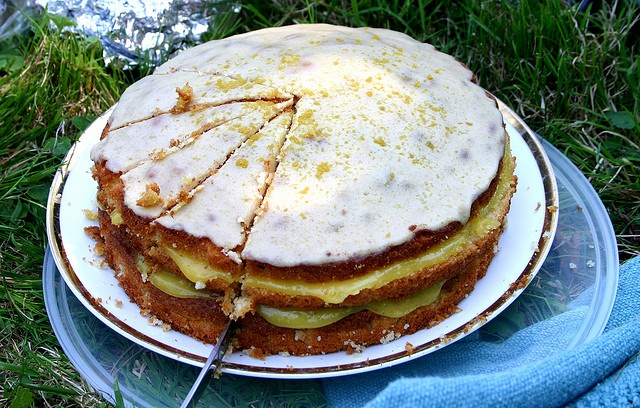Describe the objects in this image and their specific colors. I can see cake in gray, lightgray, maroon, beige, and black tones and knife in gray, black, lightblue, and lavender tones in this image. 